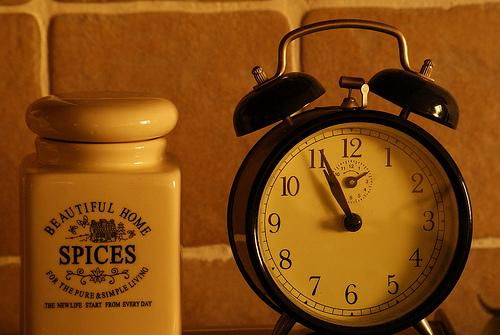Identify the items placed on the table and their colors. There's a black alarm clock and a glass jar with spices inside it. The wall in the background has brown colored tiles. Tell me about the key objects in the image and their features. There's an alarm clock with needles, a handle, and alarm bells, sitting on a table. There's also a glass jar, containing spices and having a round cap, featuring text and pictures on it. The background consists of brown color wall tiles. What type of sentiment does the image evoke, and why? The image evokes a warm, homely sentiment because of the combination of the vintage clock and the cozy spices jar placed together, creating a sense of nostalgia. What type of reasoning does the image prompt you to have concerning the objects' functions? The image prompts the idea of time and spices being essential elements in a home setting - with the clock representing the importance of time, and the jar holding spices signifying the importance of flavors and home cooking. What time does the clock show, and what are the colors of the clock's hand and background? The clock shows 10:55, and it has black needles on a white background. How many objects are present in the image, and are they interacting in any way? There are two main objects present in the image - an alarm clock and a spice jar. They're placed together on the table, but not interacting with each other. What can you infer about the relationship between the objects on the table? The alarm clock and spice jar are placed together on the table, possibly as elements of a home decor setup.  What kind of wall is behind the table, and describe its color and design? The wall behind the table is made of brown square ceramic tiles with white grout, giving it a brick-like appearance. Based on the image, what can you say about the room's decoration style? The room seems to have a vintage and rustic decoration style, with a classic alarm clock and a spice jar against a brown tiled wall. Describe the design elements and details on the jar sitting on the table. The jar has a round lid, with text and images adorned on it. One image features a beautiful home, while another shows two butterflies flying. The jar contains home spices. Does the spice jar have a round or square lid? Round Can you identify the pink unicorn on the right side of the jar? The pink unicorn is believed to bring good luck and happiness. Did you notice that the clock is mounted on a golden stand? The golden stand adds a touch of elegance to the clock. Identify how the clock hands are positioned in the image. Both hands are at 11 Explain the layout of the clocks within the main alarm clock in terms of arrangement. There is a small clock within the bigger clock, both showing the same time. What action is being performed by the two butterflies in the image? Flying What do you think is the temperature reading on the thermometer hanging on the wall? The thermometer seems to be displaying a comfortable room temperature. What text appears on the spice jar? READER'S DIGEST Home Library Describe the scene in a poetic manner mentioning the alarm clock, spice jar, and the wall. A vintage alarm clock whispers time, a spice jar reveals fragrant secrets, and the ceramic square tiles form a textured backdrop. Is the cat sitting on the table, next to the spice jar, looking out the window? The cat seems to be enjoying the view outside. Describe the spice container's design including the illustration it carries. The spice jar is made of glass, has a round lid, and features an illustration of a small home with two butterflies flying nearby. Create a product review for a vintage alarm clock and spice jar set based on the image. This vintage alarm clock and spice jar set adds a touch of charm to any space. The clock sports a classic design with a smaller clock inside and bold, black hands. The spice jar, adorned with a scenic illustration, stores your prized spices with elegance. Can you spot the framed picture of the Eiffel Tower resting against the wall? The framed picture of the Eiffel Tower adds a touch of romance to the scene. Which object has a picture of a building on it? Spice jar What is the state of the alarm clock? Sitting on a table Observe the intricate design of the potted plants placed just behind the alarm clock. The potted plants add a soothing touch to the scene. What is the secondary event happening in the scene involving the butterflies? Two butterflies flying Describe the alarm clock using its color, shape, and features. The alarm clock is black, round and has two bells on top, a handle, and three needles - two black needles and one red alarm needle. What does the alarm clock indicate the time as? 10:55 In a single sentence, describe the scene mentioning the objects on the table and the wall. A black vintage alarm clock and a glass spice jar rest on a table, set against a wall adorned with brown ceramic square tiles. Identify the primary event taking place in the image involving the two main objects. Clock showing the time and spice jar sitting on a table What color are the numbers on the clock? Black 